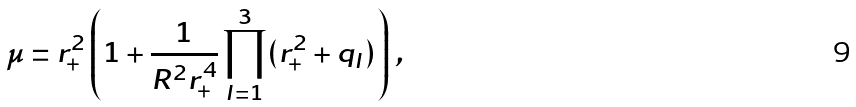<formula> <loc_0><loc_0><loc_500><loc_500>\mu = r _ { + } ^ { 2 } \left ( 1 + \frac { 1 } { R ^ { 2 } r _ { + } ^ { 4 } } \prod _ { I = 1 } ^ { 3 } ( r _ { + } ^ { 2 } + q _ { I } ) \right ) \, ,</formula> 